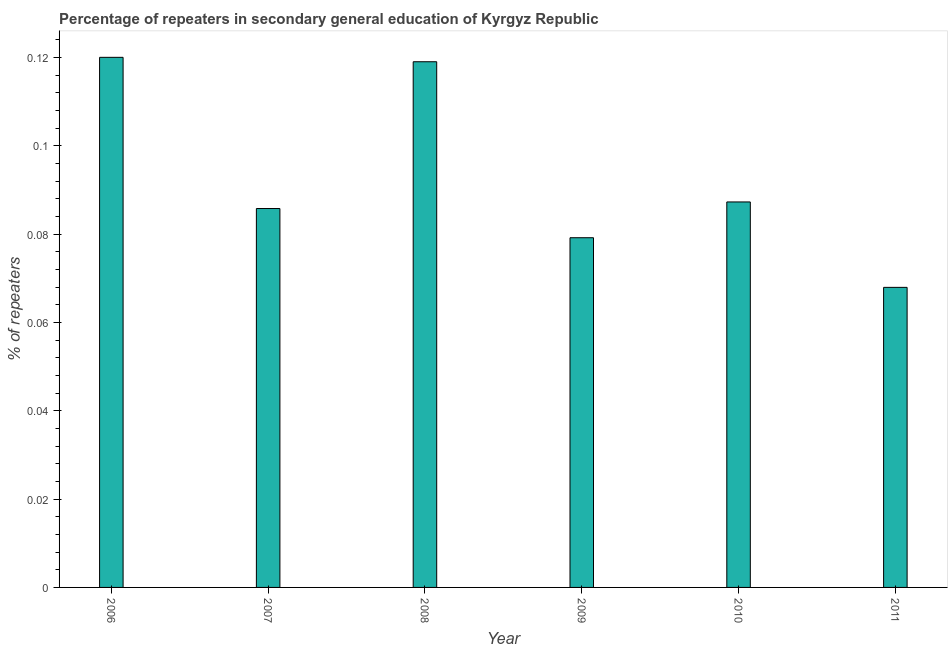Does the graph contain any zero values?
Your answer should be compact. No. Does the graph contain grids?
Your answer should be compact. No. What is the title of the graph?
Offer a terse response. Percentage of repeaters in secondary general education of Kyrgyz Republic. What is the label or title of the Y-axis?
Offer a terse response. % of repeaters. What is the percentage of repeaters in 2011?
Keep it short and to the point. 0.07. Across all years, what is the maximum percentage of repeaters?
Ensure brevity in your answer.  0.12. Across all years, what is the minimum percentage of repeaters?
Keep it short and to the point. 0.07. In which year was the percentage of repeaters minimum?
Your answer should be compact. 2011. What is the sum of the percentage of repeaters?
Keep it short and to the point. 0.56. What is the difference between the percentage of repeaters in 2006 and 2008?
Make the answer very short. 0. What is the average percentage of repeaters per year?
Ensure brevity in your answer.  0.09. What is the median percentage of repeaters?
Your answer should be very brief. 0.09. In how many years, is the percentage of repeaters greater than 0.116 %?
Offer a very short reply. 2. What is the ratio of the percentage of repeaters in 2006 to that in 2007?
Your response must be concise. 1.4. Is the sum of the percentage of repeaters in 2006 and 2008 greater than the maximum percentage of repeaters across all years?
Ensure brevity in your answer.  Yes. What is the difference between the highest and the lowest percentage of repeaters?
Your answer should be very brief. 0.05. In how many years, is the percentage of repeaters greater than the average percentage of repeaters taken over all years?
Your answer should be compact. 2. Are all the bars in the graph horizontal?
Offer a terse response. No. How many years are there in the graph?
Your answer should be very brief. 6. What is the % of repeaters of 2006?
Offer a terse response. 0.12. What is the % of repeaters of 2007?
Your answer should be very brief. 0.09. What is the % of repeaters in 2008?
Your response must be concise. 0.12. What is the % of repeaters in 2009?
Provide a succinct answer. 0.08. What is the % of repeaters in 2010?
Keep it short and to the point. 0.09. What is the % of repeaters in 2011?
Offer a terse response. 0.07. What is the difference between the % of repeaters in 2006 and 2007?
Make the answer very short. 0.03. What is the difference between the % of repeaters in 2006 and 2008?
Provide a succinct answer. 0. What is the difference between the % of repeaters in 2006 and 2009?
Offer a terse response. 0.04. What is the difference between the % of repeaters in 2006 and 2010?
Your answer should be very brief. 0.03. What is the difference between the % of repeaters in 2006 and 2011?
Give a very brief answer. 0.05. What is the difference between the % of repeaters in 2007 and 2008?
Provide a short and direct response. -0.03. What is the difference between the % of repeaters in 2007 and 2009?
Give a very brief answer. 0.01. What is the difference between the % of repeaters in 2007 and 2010?
Give a very brief answer. -0. What is the difference between the % of repeaters in 2007 and 2011?
Provide a succinct answer. 0.02. What is the difference between the % of repeaters in 2008 and 2009?
Keep it short and to the point. 0.04. What is the difference between the % of repeaters in 2008 and 2010?
Ensure brevity in your answer.  0.03. What is the difference between the % of repeaters in 2008 and 2011?
Your answer should be very brief. 0.05. What is the difference between the % of repeaters in 2009 and 2010?
Your answer should be compact. -0.01. What is the difference between the % of repeaters in 2009 and 2011?
Provide a short and direct response. 0.01. What is the difference between the % of repeaters in 2010 and 2011?
Ensure brevity in your answer.  0.02. What is the ratio of the % of repeaters in 2006 to that in 2007?
Give a very brief answer. 1.4. What is the ratio of the % of repeaters in 2006 to that in 2008?
Provide a succinct answer. 1.01. What is the ratio of the % of repeaters in 2006 to that in 2009?
Offer a terse response. 1.52. What is the ratio of the % of repeaters in 2006 to that in 2010?
Your response must be concise. 1.38. What is the ratio of the % of repeaters in 2006 to that in 2011?
Give a very brief answer. 1.77. What is the ratio of the % of repeaters in 2007 to that in 2008?
Keep it short and to the point. 0.72. What is the ratio of the % of repeaters in 2007 to that in 2009?
Ensure brevity in your answer.  1.08. What is the ratio of the % of repeaters in 2007 to that in 2011?
Your answer should be very brief. 1.26. What is the ratio of the % of repeaters in 2008 to that in 2009?
Make the answer very short. 1.5. What is the ratio of the % of repeaters in 2008 to that in 2010?
Give a very brief answer. 1.36. What is the ratio of the % of repeaters in 2008 to that in 2011?
Provide a succinct answer. 1.75. What is the ratio of the % of repeaters in 2009 to that in 2010?
Keep it short and to the point. 0.91. What is the ratio of the % of repeaters in 2009 to that in 2011?
Ensure brevity in your answer.  1.17. What is the ratio of the % of repeaters in 2010 to that in 2011?
Offer a very short reply. 1.28. 